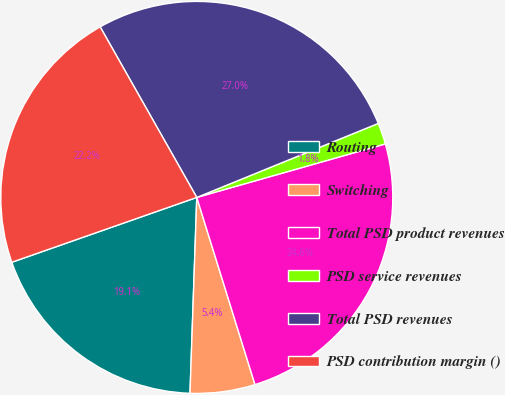Convert chart to OTSL. <chart><loc_0><loc_0><loc_500><loc_500><pie_chart><fcel>Routing<fcel>Switching<fcel>Total PSD product revenues<fcel>PSD service revenues<fcel>Total PSD revenues<fcel>PSD contribution margin ()<nl><fcel>19.08%<fcel>5.35%<fcel>24.6%<fcel>1.76%<fcel>27.04%<fcel>22.16%<nl></chart> 